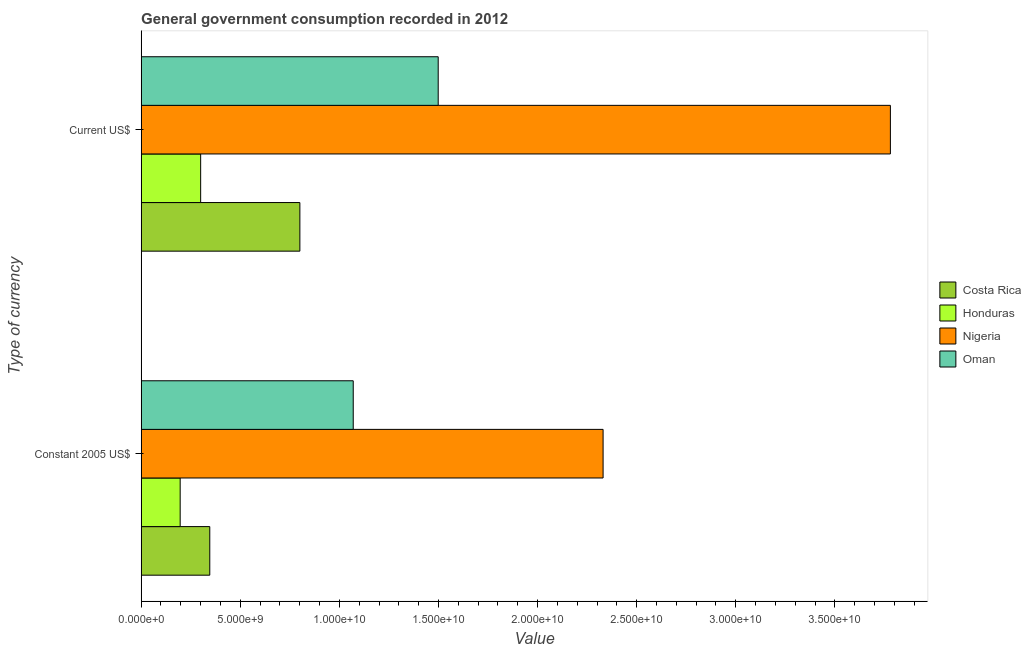Are the number of bars on each tick of the Y-axis equal?
Make the answer very short. Yes. How many bars are there on the 1st tick from the top?
Provide a succinct answer. 4. How many bars are there on the 1st tick from the bottom?
Make the answer very short. 4. What is the label of the 1st group of bars from the top?
Make the answer very short. Current US$. What is the value consumed in constant 2005 us$ in Nigeria?
Your answer should be very brief. 2.33e+1. Across all countries, what is the maximum value consumed in constant 2005 us$?
Ensure brevity in your answer.  2.33e+1. Across all countries, what is the minimum value consumed in constant 2005 us$?
Your response must be concise. 1.97e+09. In which country was the value consumed in constant 2005 us$ maximum?
Give a very brief answer. Nigeria. In which country was the value consumed in current us$ minimum?
Provide a succinct answer. Honduras. What is the total value consumed in current us$ in the graph?
Your answer should be compact. 6.38e+1. What is the difference between the value consumed in constant 2005 us$ in Nigeria and that in Oman?
Your answer should be compact. 1.26e+1. What is the difference between the value consumed in current us$ in Costa Rica and the value consumed in constant 2005 us$ in Oman?
Offer a very short reply. -2.69e+09. What is the average value consumed in constant 2005 us$ per country?
Make the answer very short. 9.86e+09. What is the difference between the value consumed in current us$ and value consumed in constant 2005 us$ in Honduras?
Your response must be concise. 1.03e+09. What is the ratio of the value consumed in current us$ in Oman to that in Honduras?
Provide a short and direct response. 4.99. In how many countries, is the value consumed in constant 2005 us$ greater than the average value consumed in constant 2005 us$ taken over all countries?
Offer a very short reply. 2. What does the 1st bar from the top in Current US$ represents?
Your answer should be compact. Oman. What does the 2nd bar from the bottom in Current US$ represents?
Ensure brevity in your answer.  Honduras. How many bars are there?
Your response must be concise. 8. Are all the bars in the graph horizontal?
Offer a very short reply. Yes. How many countries are there in the graph?
Give a very brief answer. 4. Does the graph contain grids?
Give a very brief answer. No. Where does the legend appear in the graph?
Offer a very short reply. Center right. How are the legend labels stacked?
Offer a terse response. Vertical. What is the title of the graph?
Your answer should be compact. General government consumption recorded in 2012. What is the label or title of the X-axis?
Offer a very short reply. Value. What is the label or title of the Y-axis?
Offer a terse response. Type of currency. What is the Value in Costa Rica in Constant 2005 US$?
Make the answer very short. 3.46e+09. What is the Value of Honduras in Constant 2005 US$?
Give a very brief answer. 1.97e+09. What is the Value of Nigeria in Constant 2005 US$?
Your response must be concise. 2.33e+1. What is the Value in Oman in Constant 2005 US$?
Make the answer very short. 1.07e+1. What is the Value of Costa Rica in Current US$?
Provide a succinct answer. 8.01e+09. What is the Value of Honduras in Current US$?
Offer a very short reply. 3.00e+09. What is the Value in Nigeria in Current US$?
Your answer should be compact. 3.78e+1. What is the Value of Oman in Current US$?
Ensure brevity in your answer.  1.50e+1. Across all Type of currency, what is the maximum Value of Costa Rica?
Keep it short and to the point. 8.01e+09. Across all Type of currency, what is the maximum Value of Honduras?
Ensure brevity in your answer.  3.00e+09. Across all Type of currency, what is the maximum Value of Nigeria?
Your answer should be compact. 3.78e+1. Across all Type of currency, what is the maximum Value of Oman?
Provide a succinct answer. 1.50e+1. Across all Type of currency, what is the minimum Value in Costa Rica?
Make the answer very short. 3.46e+09. Across all Type of currency, what is the minimum Value of Honduras?
Give a very brief answer. 1.97e+09. Across all Type of currency, what is the minimum Value in Nigeria?
Provide a succinct answer. 2.33e+1. Across all Type of currency, what is the minimum Value in Oman?
Offer a terse response. 1.07e+1. What is the total Value of Costa Rica in the graph?
Make the answer very short. 1.15e+1. What is the total Value of Honduras in the graph?
Provide a succinct answer. 4.97e+09. What is the total Value in Nigeria in the graph?
Offer a very short reply. 6.11e+1. What is the total Value in Oman in the graph?
Your answer should be very brief. 2.57e+1. What is the difference between the Value of Costa Rica in Constant 2005 US$ and that in Current US$?
Provide a short and direct response. -4.54e+09. What is the difference between the Value in Honduras in Constant 2005 US$ and that in Current US$?
Your answer should be very brief. -1.03e+09. What is the difference between the Value of Nigeria in Constant 2005 US$ and that in Current US$?
Give a very brief answer. -1.45e+1. What is the difference between the Value of Oman in Constant 2005 US$ and that in Current US$?
Your answer should be very brief. -4.29e+09. What is the difference between the Value in Costa Rica in Constant 2005 US$ and the Value in Honduras in Current US$?
Your answer should be very brief. 4.61e+08. What is the difference between the Value of Costa Rica in Constant 2005 US$ and the Value of Nigeria in Current US$?
Provide a succinct answer. -3.43e+1. What is the difference between the Value in Costa Rica in Constant 2005 US$ and the Value in Oman in Current US$?
Provide a succinct answer. -1.15e+1. What is the difference between the Value in Honduras in Constant 2005 US$ and the Value in Nigeria in Current US$?
Provide a short and direct response. -3.58e+1. What is the difference between the Value in Honduras in Constant 2005 US$ and the Value in Oman in Current US$?
Offer a terse response. -1.30e+1. What is the difference between the Value of Nigeria in Constant 2005 US$ and the Value of Oman in Current US$?
Your answer should be compact. 8.32e+09. What is the average Value in Costa Rica per Type of currency?
Your response must be concise. 5.73e+09. What is the average Value in Honduras per Type of currency?
Offer a terse response. 2.49e+09. What is the average Value in Nigeria per Type of currency?
Make the answer very short. 3.06e+1. What is the average Value of Oman per Type of currency?
Make the answer very short. 1.28e+1. What is the difference between the Value of Costa Rica and Value of Honduras in Constant 2005 US$?
Your answer should be compact. 1.49e+09. What is the difference between the Value of Costa Rica and Value of Nigeria in Constant 2005 US$?
Your answer should be compact. -1.98e+1. What is the difference between the Value in Costa Rica and Value in Oman in Constant 2005 US$?
Make the answer very short. -7.24e+09. What is the difference between the Value of Honduras and Value of Nigeria in Constant 2005 US$?
Ensure brevity in your answer.  -2.13e+1. What is the difference between the Value in Honduras and Value in Oman in Constant 2005 US$?
Give a very brief answer. -8.73e+09. What is the difference between the Value of Nigeria and Value of Oman in Constant 2005 US$?
Give a very brief answer. 1.26e+1. What is the difference between the Value in Costa Rica and Value in Honduras in Current US$?
Make the answer very short. 5.01e+09. What is the difference between the Value of Costa Rica and Value of Nigeria in Current US$?
Keep it short and to the point. -2.98e+1. What is the difference between the Value of Costa Rica and Value of Oman in Current US$?
Provide a short and direct response. -6.98e+09. What is the difference between the Value in Honduras and Value in Nigeria in Current US$?
Your answer should be very brief. -3.48e+1. What is the difference between the Value of Honduras and Value of Oman in Current US$?
Your answer should be very brief. -1.20e+1. What is the difference between the Value in Nigeria and Value in Oman in Current US$?
Give a very brief answer. 2.28e+1. What is the ratio of the Value of Costa Rica in Constant 2005 US$ to that in Current US$?
Provide a succinct answer. 0.43. What is the ratio of the Value in Honduras in Constant 2005 US$ to that in Current US$?
Your answer should be compact. 0.66. What is the ratio of the Value in Nigeria in Constant 2005 US$ to that in Current US$?
Provide a short and direct response. 0.62. What is the ratio of the Value in Oman in Constant 2005 US$ to that in Current US$?
Your answer should be compact. 0.71. What is the difference between the highest and the second highest Value of Costa Rica?
Keep it short and to the point. 4.54e+09. What is the difference between the highest and the second highest Value in Honduras?
Make the answer very short. 1.03e+09. What is the difference between the highest and the second highest Value in Nigeria?
Your response must be concise. 1.45e+1. What is the difference between the highest and the second highest Value of Oman?
Offer a terse response. 4.29e+09. What is the difference between the highest and the lowest Value in Costa Rica?
Ensure brevity in your answer.  4.54e+09. What is the difference between the highest and the lowest Value of Honduras?
Ensure brevity in your answer.  1.03e+09. What is the difference between the highest and the lowest Value of Nigeria?
Keep it short and to the point. 1.45e+1. What is the difference between the highest and the lowest Value in Oman?
Offer a very short reply. 4.29e+09. 